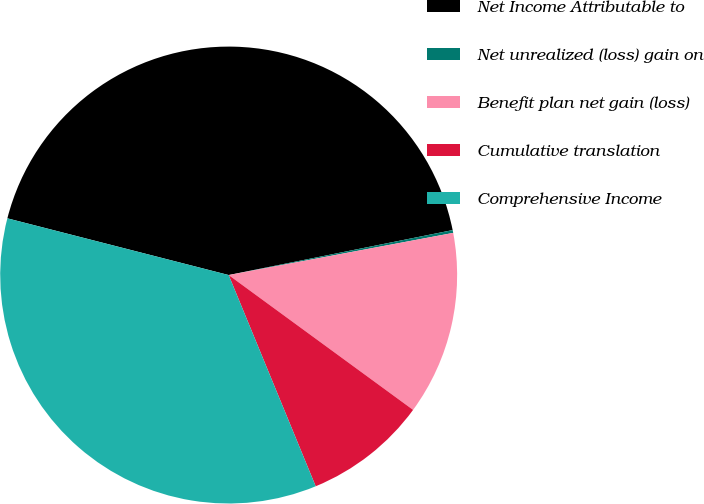Convert chart to OTSL. <chart><loc_0><loc_0><loc_500><loc_500><pie_chart><fcel>Net Income Attributable to<fcel>Net unrealized (loss) gain on<fcel>Benefit plan net gain (loss)<fcel>Cumulative translation<fcel>Comprehensive Income<nl><fcel>42.85%<fcel>0.2%<fcel>13.0%<fcel>8.73%<fcel>35.21%<nl></chart> 